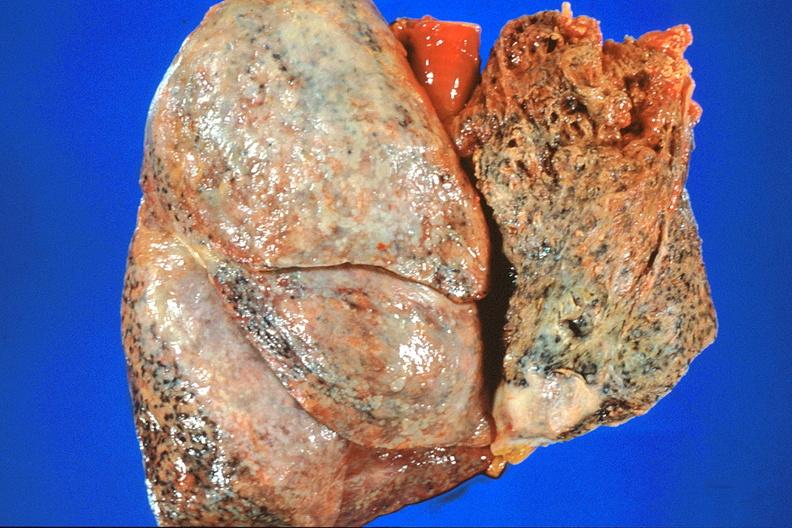does hypospadias show lung, asbestosis and mesothelioma?
Answer the question using a single word or phrase. No 